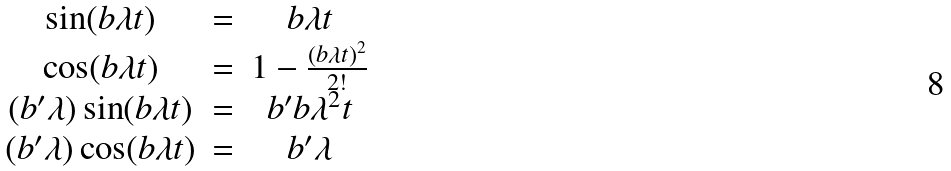Convert formula to latex. <formula><loc_0><loc_0><loc_500><loc_500>\begin{array} { c c c } \sin ( b \lambda t ) & = & b \lambda t \\ \cos ( b \lambda t ) & = & 1 - \frac { ( b \lambda t ) ^ { 2 } } { 2 ! } \\ ( b ^ { \prime } \lambda ) \sin ( b \lambda t ) & = & b ^ { \prime } b \lambda ^ { 2 } t \\ ( b ^ { \prime } \lambda ) \cos ( b \lambda t ) & = & b ^ { \prime } \lambda \end{array}</formula> 